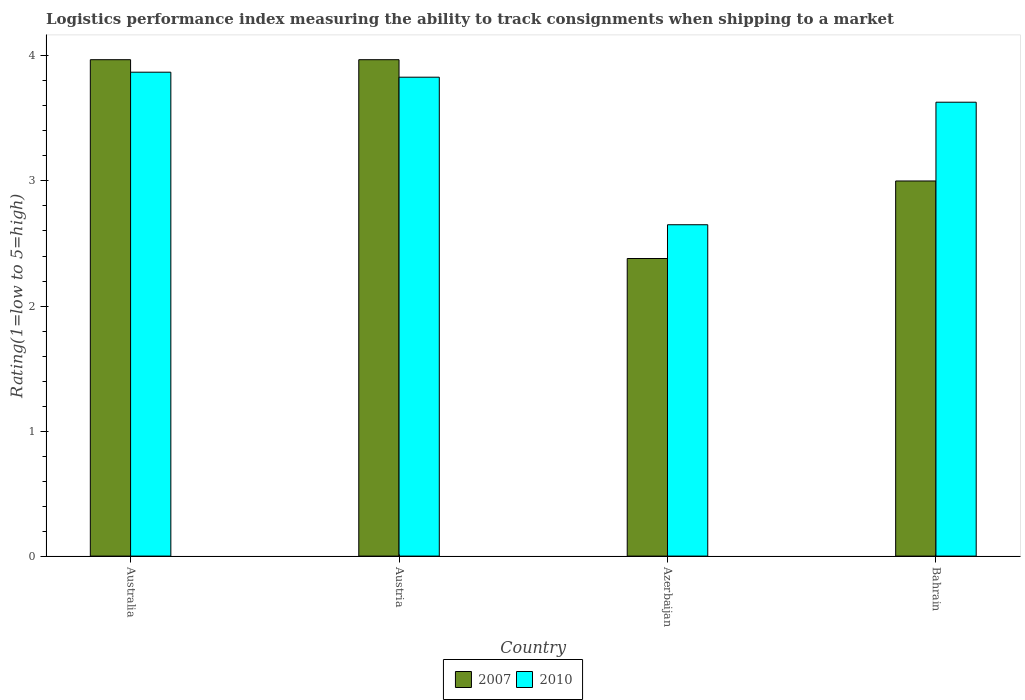Are the number of bars on each tick of the X-axis equal?
Your answer should be compact. Yes. How many bars are there on the 4th tick from the right?
Offer a terse response. 2. What is the label of the 2nd group of bars from the left?
Provide a short and direct response. Austria. In how many cases, is the number of bars for a given country not equal to the number of legend labels?
Offer a terse response. 0. What is the Logistic performance index in 2010 in Australia?
Your response must be concise. 3.87. Across all countries, what is the maximum Logistic performance index in 2010?
Your answer should be compact. 3.87. Across all countries, what is the minimum Logistic performance index in 2007?
Give a very brief answer. 2.38. In which country was the Logistic performance index in 2007 maximum?
Make the answer very short. Australia. In which country was the Logistic performance index in 2007 minimum?
Ensure brevity in your answer.  Azerbaijan. What is the total Logistic performance index in 2010 in the graph?
Give a very brief answer. 13.98. What is the difference between the Logistic performance index in 2010 in Australia and that in Bahrain?
Ensure brevity in your answer.  0.24. What is the difference between the Logistic performance index in 2010 in Azerbaijan and the Logistic performance index in 2007 in Bahrain?
Provide a short and direct response. -0.35. What is the average Logistic performance index in 2010 per country?
Your answer should be compact. 3.5. What is the difference between the Logistic performance index of/in 2007 and Logistic performance index of/in 2010 in Australia?
Make the answer very short. 0.1. In how many countries, is the Logistic performance index in 2007 greater than 1?
Keep it short and to the point. 4. What is the ratio of the Logistic performance index in 2010 in Australia to that in Azerbaijan?
Give a very brief answer. 1.46. What is the difference between the highest and the second highest Logistic performance index in 2007?
Your response must be concise. -0.97. What is the difference between the highest and the lowest Logistic performance index in 2010?
Your answer should be very brief. 1.22. In how many countries, is the Logistic performance index in 2010 greater than the average Logistic performance index in 2010 taken over all countries?
Your answer should be compact. 3. Is the sum of the Logistic performance index in 2007 in Australia and Austria greater than the maximum Logistic performance index in 2010 across all countries?
Offer a very short reply. Yes. What does the 1st bar from the right in Bahrain represents?
Offer a terse response. 2010. What is the difference between two consecutive major ticks on the Y-axis?
Your response must be concise. 1. Are the values on the major ticks of Y-axis written in scientific E-notation?
Give a very brief answer. No. Does the graph contain any zero values?
Provide a succinct answer. No. Does the graph contain grids?
Provide a succinct answer. No. How many legend labels are there?
Your answer should be very brief. 2. How are the legend labels stacked?
Keep it short and to the point. Horizontal. What is the title of the graph?
Offer a very short reply. Logistics performance index measuring the ability to track consignments when shipping to a market. What is the label or title of the X-axis?
Your response must be concise. Country. What is the label or title of the Y-axis?
Your answer should be compact. Rating(1=low to 5=high). What is the Rating(1=low to 5=high) in 2007 in Australia?
Give a very brief answer. 3.97. What is the Rating(1=low to 5=high) in 2010 in Australia?
Provide a succinct answer. 3.87. What is the Rating(1=low to 5=high) in 2007 in Austria?
Keep it short and to the point. 3.97. What is the Rating(1=low to 5=high) of 2010 in Austria?
Keep it short and to the point. 3.83. What is the Rating(1=low to 5=high) in 2007 in Azerbaijan?
Your answer should be compact. 2.38. What is the Rating(1=low to 5=high) in 2010 in Azerbaijan?
Keep it short and to the point. 2.65. What is the Rating(1=low to 5=high) of 2010 in Bahrain?
Offer a very short reply. 3.63. Across all countries, what is the maximum Rating(1=low to 5=high) in 2007?
Provide a succinct answer. 3.97. Across all countries, what is the maximum Rating(1=low to 5=high) of 2010?
Make the answer very short. 3.87. Across all countries, what is the minimum Rating(1=low to 5=high) of 2007?
Your answer should be very brief. 2.38. Across all countries, what is the minimum Rating(1=low to 5=high) of 2010?
Your response must be concise. 2.65. What is the total Rating(1=low to 5=high) of 2007 in the graph?
Offer a terse response. 13.32. What is the total Rating(1=low to 5=high) in 2010 in the graph?
Keep it short and to the point. 13.98. What is the difference between the Rating(1=low to 5=high) of 2007 in Australia and that in Austria?
Your answer should be very brief. 0. What is the difference between the Rating(1=low to 5=high) of 2007 in Australia and that in Azerbaijan?
Offer a very short reply. 1.59. What is the difference between the Rating(1=low to 5=high) in 2010 in Australia and that in Azerbaijan?
Your answer should be very brief. 1.22. What is the difference between the Rating(1=low to 5=high) in 2007 in Australia and that in Bahrain?
Provide a succinct answer. 0.97. What is the difference between the Rating(1=low to 5=high) in 2010 in Australia and that in Bahrain?
Provide a succinct answer. 0.24. What is the difference between the Rating(1=low to 5=high) of 2007 in Austria and that in Azerbaijan?
Your response must be concise. 1.59. What is the difference between the Rating(1=low to 5=high) of 2010 in Austria and that in Azerbaijan?
Your answer should be compact. 1.18. What is the difference between the Rating(1=low to 5=high) of 2007 in Austria and that in Bahrain?
Your answer should be compact. 0.97. What is the difference between the Rating(1=low to 5=high) of 2010 in Austria and that in Bahrain?
Give a very brief answer. 0.2. What is the difference between the Rating(1=low to 5=high) in 2007 in Azerbaijan and that in Bahrain?
Give a very brief answer. -0.62. What is the difference between the Rating(1=low to 5=high) in 2010 in Azerbaijan and that in Bahrain?
Offer a terse response. -0.98. What is the difference between the Rating(1=low to 5=high) in 2007 in Australia and the Rating(1=low to 5=high) in 2010 in Austria?
Keep it short and to the point. 0.14. What is the difference between the Rating(1=low to 5=high) of 2007 in Australia and the Rating(1=low to 5=high) of 2010 in Azerbaijan?
Ensure brevity in your answer.  1.32. What is the difference between the Rating(1=low to 5=high) of 2007 in Australia and the Rating(1=low to 5=high) of 2010 in Bahrain?
Give a very brief answer. 0.34. What is the difference between the Rating(1=low to 5=high) of 2007 in Austria and the Rating(1=low to 5=high) of 2010 in Azerbaijan?
Provide a short and direct response. 1.32. What is the difference between the Rating(1=low to 5=high) in 2007 in Austria and the Rating(1=low to 5=high) in 2010 in Bahrain?
Your response must be concise. 0.34. What is the difference between the Rating(1=low to 5=high) in 2007 in Azerbaijan and the Rating(1=low to 5=high) in 2010 in Bahrain?
Ensure brevity in your answer.  -1.25. What is the average Rating(1=low to 5=high) in 2007 per country?
Ensure brevity in your answer.  3.33. What is the average Rating(1=low to 5=high) in 2010 per country?
Keep it short and to the point. 3.5. What is the difference between the Rating(1=low to 5=high) of 2007 and Rating(1=low to 5=high) of 2010 in Australia?
Offer a very short reply. 0.1. What is the difference between the Rating(1=low to 5=high) in 2007 and Rating(1=low to 5=high) in 2010 in Austria?
Provide a short and direct response. 0.14. What is the difference between the Rating(1=low to 5=high) in 2007 and Rating(1=low to 5=high) in 2010 in Azerbaijan?
Your response must be concise. -0.27. What is the difference between the Rating(1=low to 5=high) in 2007 and Rating(1=low to 5=high) in 2010 in Bahrain?
Your response must be concise. -0.63. What is the ratio of the Rating(1=low to 5=high) in 2007 in Australia to that in Austria?
Your answer should be compact. 1. What is the ratio of the Rating(1=low to 5=high) of 2010 in Australia to that in Austria?
Provide a succinct answer. 1.01. What is the ratio of the Rating(1=low to 5=high) in 2007 in Australia to that in Azerbaijan?
Provide a short and direct response. 1.67. What is the ratio of the Rating(1=low to 5=high) of 2010 in Australia to that in Azerbaijan?
Ensure brevity in your answer.  1.46. What is the ratio of the Rating(1=low to 5=high) of 2007 in Australia to that in Bahrain?
Make the answer very short. 1.32. What is the ratio of the Rating(1=low to 5=high) in 2010 in Australia to that in Bahrain?
Make the answer very short. 1.07. What is the ratio of the Rating(1=low to 5=high) of 2007 in Austria to that in Azerbaijan?
Provide a succinct answer. 1.67. What is the ratio of the Rating(1=low to 5=high) of 2010 in Austria to that in Azerbaijan?
Your answer should be compact. 1.45. What is the ratio of the Rating(1=low to 5=high) in 2007 in Austria to that in Bahrain?
Offer a very short reply. 1.32. What is the ratio of the Rating(1=low to 5=high) in 2010 in Austria to that in Bahrain?
Your response must be concise. 1.06. What is the ratio of the Rating(1=low to 5=high) in 2007 in Azerbaijan to that in Bahrain?
Offer a very short reply. 0.79. What is the ratio of the Rating(1=low to 5=high) in 2010 in Azerbaijan to that in Bahrain?
Offer a very short reply. 0.73. What is the difference between the highest and the second highest Rating(1=low to 5=high) of 2007?
Your answer should be compact. 0. What is the difference between the highest and the second highest Rating(1=low to 5=high) in 2010?
Keep it short and to the point. 0.04. What is the difference between the highest and the lowest Rating(1=low to 5=high) of 2007?
Make the answer very short. 1.59. What is the difference between the highest and the lowest Rating(1=low to 5=high) of 2010?
Keep it short and to the point. 1.22. 